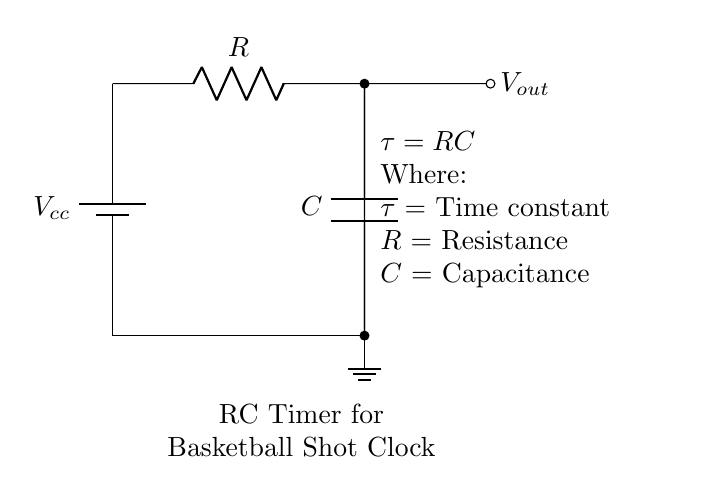What type of circuit is represented? This circuit is an RC timing circuit, which uses a resistor and a capacitor to create a time delay. The "RC" implies it utilizes these two components for its operation.
Answer: RC timing What components are included in the circuit? The circuit consists of a resistor and a capacitor connected to a battery. These components can be identified by the labels R and C in the diagram.
Answer: Resistor and capacitor What is the function of the capacitor in this circuit? The capacitor in this circuit stores charge and affects the timing interval for the output voltage change. Its charging and discharging process contributes to the time constant.
Answer: To store charge What is the time constant formula shown in the circuit? The time constant is given as τ = RC, indicating that the time constant (τ) is the product of resistance (R) and capacitance (C). This relationship is critical for determining the timing interval of the circuit.
Answer: τ = RC What does the output voltage represent? The output voltage (V_out) represents the voltage across the capacitor, which changes over time as it charges and discharges in response to the input from the battery and the resistor.
Answer: Voltage across capacitor How can increasing the resistance affect the timing? Increasing the resistance (R) will increase the time constant (τ), leading to a longer delay before the output voltage reaches a certain level. This means that the timing interval is directly proportional to resistance in this RC circuit.
Answer: Longer timing interval What happens to the output voltage when the capacitor is fully charged? When the capacitor is fully charged, the output voltage stabilizes and reaches the supply voltage (V_cc). At this point, the capacitor stops drawing current, indicating it's fully charged.
Answer: Stabilizes at V_cc 